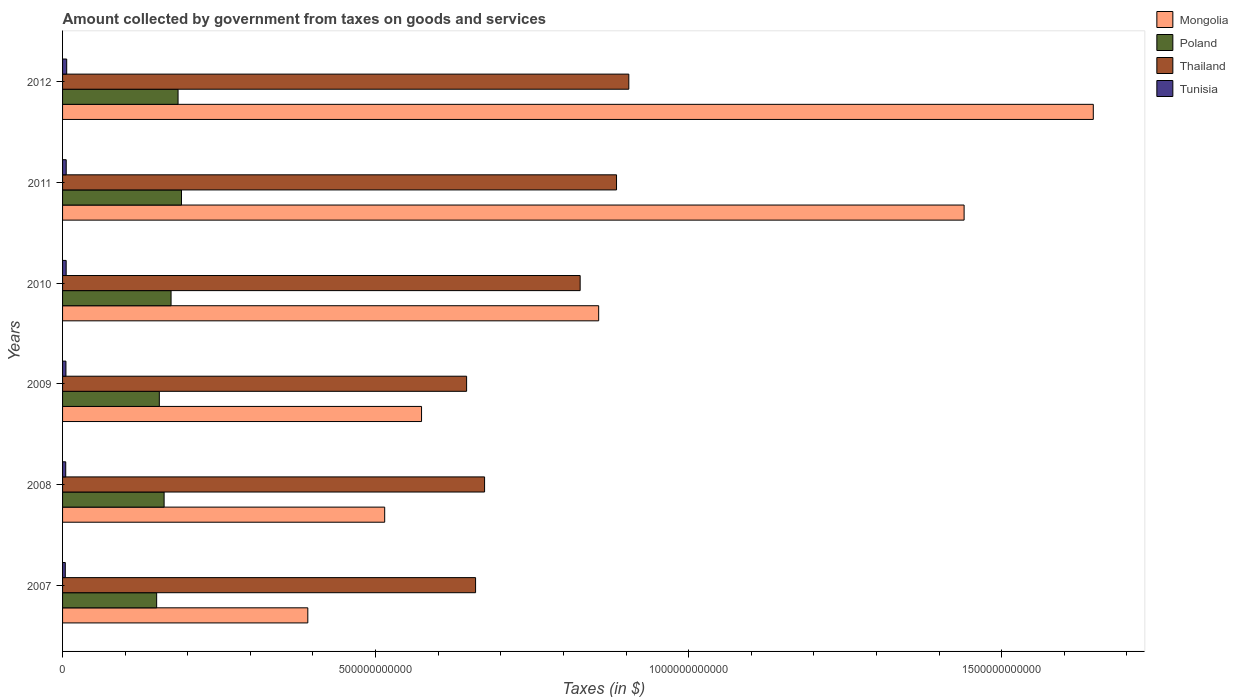How many different coloured bars are there?
Your response must be concise. 4. How many bars are there on the 6th tick from the top?
Your answer should be compact. 4. How many bars are there on the 4th tick from the bottom?
Your response must be concise. 4. What is the label of the 6th group of bars from the top?
Ensure brevity in your answer.  2007. In how many cases, is the number of bars for a given year not equal to the number of legend labels?
Keep it short and to the point. 0. What is the amount collected by government from taxes on goods and services in Poland in 2012?
Offer a very short reply. 1.84e+11. Across all years, what is the maximum amount collected by government from taxes on goods and services in Poland?
Your answer should be very brief. 1.90e+11. Across all years, what is the minimum amount collected by government from taxes on goods and services in Poland?
Your answer should be very brief. 1.50e+11. In which year was the amount collected by government from taxes on goods and services in Mongolia minimum?
Offer a terse response. 2007. What is the total amount collected by government from taxes on goods and services in Thailand in the graph?
Your answer should be compact. 4.60e+12. What is the difference between the amount collected by government from taxes on goods and services in Mongolia in 2010 and that in 2012?
Your answer should be very brief. -7.90e+11. What is the difference between the amount collected by government from taxes on goods and services in Poland in 2007 and the amount collected by government from taxes on goods and services in Tunisia in 2012?
Your response must be concise. 1.44e+11. What is the average amount collected by government from taxes on goods and services in Thailand per year?
Ensure brevity in your answer.  7.66e+11. In the year 2009, what is the difference between the amount collected by government from taxes on goods and services in Tunisia and amount collected by government from taxes on goods and services in Poland?
Provide a succinct answer. -1.49e+11. In how many years, is the amount collected by government from taxes on goods and services in Poland greater than 1300000000000 $?
Your answer should be very brief. 0. What is the ratio of the amount collected by government from taxes on goods and services in Tunisia in 2009 to that in 2010?
Your answer should be compact. 0.94. What is the difference between the highest and the second highest amount collected by government from taxes on goods and services in Tunisia?
Offer a very short reply. 7.81e+08. What is the difference between the highest and the lowest amount collected by government from taxes on goods and services in Thailand?
Keep it short and to the point. 2.59e+11. In how many years, is the amount collected by government from taxes on goods and services in Tunisia greater than the average amount collected by government from taxes on goods and services in Tunisia taken over all years?
Offer a terse response. 3. Is it the case that in every year, the sum of the amount collected by government from taxes on goods and services in Thailand and amount collected by government from taxes on goods and services in Mongolia is greater than the sum of amount collected by government from taxes on goods and services in Tunisia and amount collected by government from taxes on goods and services in Poland?
Your response must be concise. Yes. What does the 1st bar from the top in 2008 represents?
Your answer should be very brief. Tunisia. What does the 4th bar from the bottom in 2009 represents?
Your response must be concise. Tunisia. Is it the case that in every year, the sum of the amount collected by government from taxes on goods and services in Tunisia and amount collected by government from taxes on goods and services in Mongolia is greater than the amount collected by government from taxes on goods and services in Poland?
Keep it short and to the point. Yes. How many bars are there?
Give a very brief answer. 24. How many years are there in the graph?
Your answer should be compact. 6. What is the difference between two consecutive major ticks on the X-axis?
Make the answer very short. 5.00e+11. Does the graph contain any zero values?
Ensure brevity in your answer.  No. How are the legend labels stacked?
Ensure brevity in your answer.  Vertical. What is the title of the graph?
Make the answer very short. Amount collected by government from taxes on goods and services. Does "Turkey" appear as one of the legend labels in the graph?
Provide a short and direct response. No. What is the label or title of the X-axis?
Offer a very short reply. Taxes (in $). What is the label or title of the Y-axis?
Provide a short and direct response. Years. What is the Taxes (in $) of Mongolia in 2007?
Give a very brief answer. 3.92e+11. What is the Taxes (in $) in Poland in 2007?
Your answer should be very brief. 1.50e+11. What is the Taxes (in $) in Thailand in 2007?
Make the answer very short. 6.60e+11. What is the Taxes (in $) of Tunisia in 2007?
Your answer should be very brief. 4.37e+09. What is the Taxes (in $) of Mongolia in 2008?
Ensure brevity in your answer.  5.15e+11. What is the Taxes (in $) in Poland in 2008?
Offer a very short reply. 1.62e+11. What is the Taxes (in $) in Thailand in 2008?
Offer a very short reply. 6.74e+11. What is the Taxes (in $) of Tunisia in 2008?
Keep it short and to the point. 5.06e+09. What is the Taxes (in $) of Mongolia in 2009?
Your response must be concise. 5.73e+11. What is the Taxes (in $) of Poland in 2009?
Offer a very short reply. 1.55e+11. What is the Taxes (in $) in Thailand in 2009?
Give a very brief answer. 6.45e+11. What is the Taxes (in $) of Tunisia in 2009?
Give a very brief answer. 5.38e+09. What is the Taxes (in $) in Mongolia in 2010?
Ensure brevity in your answer.  8.56e+11. What is the Taxes (in $) of Poland in 2010?
Provide a short and direct response. 1.73e+11. What is the Taxes (in $) in Thailand in 2010?
Make the answer very short. 8.27e+11. What is the Taxes (in $) in Tunisia in 2010?
Your answer should be very brief. 5.75e+09. What is the Taxes (in $) in Mongolia in 2011?
Give a very brief answer. 1.44e+12. What is the Taxes (in $) of Poland in 2011?
Give a very brief answer. 1.90e+11. What is the Taxes (in $) of Thailand in 2011?
Provide a succinct answer. 8.85e+11. What is the Taxes (in $) in Tunisia in 2011?
Your answer should be very brief. 5.83e+09. What is the Taxes (in $) of Mongolia in 2012?
Keep it short and to the point. 1.65e+12. What is the Taxes (in $) in Poland in 2012?
Make the answer very short. 1.84e+11. What is the Taxes (in $) of Thailand in 2012?
Your response must be concise. 9.04e+11. What is the Taxes (in $) of Tunisia in 2012?
Make the answer very short. 6.61e+09. Across all years, what is the maximum Taxes (in $) of Mongolia?
Make the answer very short. 1.65e+12. Across all years, what is the maximum Taxes (in $) of Poland?
Keep it short and to the point. 1.90e+11. Across all years, what is the maximum Taxes (in $) in Thailand?
Give a very brief answer. 9.04e+11. Across all years, what is the maximum Taxes (in $) in Tunisia?
Offer a terse response. 6.61e+09. Across all years, what is the minimum Taxes (in $) of Mongolia?
Offer a very short reply. 3.92e+11. Across all years, what is the minimum Taxes (in $) of Poland?
Make the answer very short. 1.50e+11. Across all years, what is the minimum Taxes (in $) in Thailand?
Offer a terse response. 6.45e+11. Across all years, what is the minimum Taxes (in $) of Tunisia?
Provide a short and direct response. 4.37e+09. What is the total Taxes (in $) in Mongolia in the graph?
Keep it short and to the point. 5.42e+12. What is the total Taxes (in $) in Poland in the graph?
Your response must be concise. 1.01e+12. What is the total Taxes (in $) of Thailand in the graph?
Keep it short and to the point. 4.60e+12. What is the total Taxes (in $) in Tunisia in the graph?
Give a very brief answer. 3.30e+1. What is the difference between the Taxes (in $) in Mongolia in 2007 and that in 2008?
Offer a terse response. -1.23e+11. What is the difference between the Taxes (in $) of Poland in 2007 and that in 2008?
Your answer should be compact. -1.19e+1. What is the difference between the Taxes (in $) in Thailand in 2007 and that in 2008?
Ensure brevity in your answer.  -1.44e+1. What is the difference between the Taxes (in $) of Tunisia in 2007 and that in 2008?
Provide a succinct answer. -6.88e+08. What is the difference between the Taxes (in $) in Mongolia in 2007 and that in 2009?
Make the answer very short. -1.82e+11. What is the difference between the Taxes (in $) in Poland in 2007 and that in 2009?
Your answer should be compact. -4.26e+09. What is the difference between the Taxes (in $) in Thailand in 2007 and that in 2009?
Your response must be concise. 1.43e+1. What is the difference between the Taxes (in $) in Tunisia in 2007 and that in 2009?
Your answer should be compact. -1.00e+09. What is the difference between the Taxes (in $) of Mongolia in 2007 and that in 2010?
Make the answer very short. -4.65e+11. What is the difference between the Taxes (in $) of Poland in 2007 and that in 2010?
Your answer should be compact. -2.30e+1. What is the difference between the Taxes (in $) in Thailand in 2007 and that in 2010?
Provide a short and direct response. -1.67e+11. What is the difference between the Taxes (in $) of Tunisia in 2007 and that in 2010?
Your answer should be very brief. -1.37e+09. What is the difference between the Taxes (in $) of Mongolia in 2007 and that in 2011?
Your answer should be very brief. -1.05e+12. What is the difference between the Taxes (in $) of Poland in 2007 and that in 2011?
Give a very brief answer. -3.97e+1. What is the difference between the Taxes (in $) of Thailand in 2007 and that in 2011?
Make the answer very short. -2.25e+11. What is the difference between the Taxes (in $) of Tunisia in 2007 and that in 2011?
Give a very brief answer. -1.45e+09. What is the difference between the Taxes (in $) of Mongolia in 2007 and that in 2012?
Keep it short and to the point. -1.25e+12. What is the difference between the Taxes (in $) in Poland in 2007 and that in 2012?
Your answer should be compact. -3.42e+1. What is the difference between the Taxes (in $) in Thailand in 2007 and that in 2012?
Offer a terse response. -2.45e+11. What is the difference between the Taxes (in $) in Tunisia in 2007 and that in 2012?
Your answer should be compact. -2.24e+09. What is the difference between the Taxes (in $) in Mongolia in 2008 and that in 2009?
Give a very brief answer. -5.89e+1. What is the difference between the Taxes (in $) of Poland in 2008 and that in 2009?
Provide a short and direct response. 7.66e+09. What is the difference between the Taxes (in $) in Thailand in 2008 and that in 2009?
Provide a succinct answer. 2.87e+1. What is the difference between the Taxes (in $) of Tunisia in 2008 and that in 2009?
Offer a terse response. -3.16e+08. What is the difference between the Taxes (in $) in Mongolia in 2008 and that in 2010?
Your answer should be very brief. -3.42e+11. What is the difference between the Taxes (in $) in Poland in 2008 and that in 2010?
Offer a terse response. -1.11e+1. What is the difference between the Taxes (in $) in Thailand in 2008 and that in 2010?
Provide a short and direct response. -1.53e+11. What is the difference between the Taxes (in $) of Tunisia in 2008 and that in 2010?
Your answer should be very brief. -6.86e+08. What is the difference between the Taxes (in $) of Mongolia in 2008 and that in 2011?
Your response must be concise. -9.26e+11. What is the difference between the Taxes (in $) in Poland in 2008 and that in 2011?
Offer a very short reply. -2.77e+1. What is the difference between the Taxes (in $) of Thailand in 2008 and that in 2011?
Offer a very short reply. -2.11e+11. What is the difference between the Taxes (in $) of Tunisia in 2008 and that in 2011?
Provide a succinct answer. -7.66e+08. What is the difference between the Taxes (in $) of Mongolia in 2008 and that in 2012?
Offer a very short reply. -1.13e+12. What is the difference between the Taxes (in $) of Poland in 2008 and that in 2012?
Your answer should be very brief. -2.23e+1. What is the difference between the Taxes (in $) in Thailand in 2008 and that in 2012?
Offer a very short reply. -2.30e+11. What is the difference between the Taxes (in $) of Tunisia in 2008 and that in 2012?
Ensure brevity in your answer.  -1.55e+09. What is the difference between the Taxes (in $) of Mongolia in 2009 and that in 2010?
Make the answer very short. -2.83e+11. What is the difference between the Taxes (in $) in Poland in 2009 and that in 2010?
Provide a short and direct response. -1.88e+1. What is the difference between the Taxes (in $) in Thailand in 2009 and that in 2010?
Keep it short and to the point. -1.81e+11. What is the difference between the Taxes (in $) of Tunisia in 2009 and that in 2010?
Your response must be concise. -3.70e+08. What is the difference between the Taxes (in $) of Mongolia in 2009 and that in 2011?
Offer a terse response. -8.67e+11. What is the difference between the Taxes (in $) of Poland in 2009 and that in 2011?
Make the answer very short. -3.54e+1. What is the difference between the Taxes (in $) in Thailand in 2009 and that in 2011?
Your answer should be very brief. -2.39e+11. What is the difference between the Taxes (in $) of Tunisia in 2009 and that in 2011?
Provide a succinct answer. -4.50e+08. What is the difference between the Taxes (in $) in Mongolia in 2009 and that in 2012?
Ensure brevity in your answer.  -1.07e+12. What is the difference between the Taxes (in $) in Poland in 2009 and that in 2012?
Provide a short and direct response. -2.99e+1. What is the difference between the Taxes (in $) of Thailand in 2009 and that in 2012?
Provide a short and direct response. -2.59e+11. What is the difference between the Taxes (in $) of Tunisia in 2009 and that in 2012?
Your answer should be very brief. -1.23e+09. What is the difference between the Taxes (in $) of Mongolia in 2010 and that in 2011?
Your response must be concise. -5.84e+11. What is the difference between the Taxes (in $) of Poland in 2010 and that in 2011?
Provide a succinct answer. -1.66e+1. What is the difference between the Taxes (in $) of Thailand in 2010 and that in 2011?
Ensure brevity in your answer.  -5.81e+1. What is the difference between the Taxes (in $) in Tunisia in 2010 and that in 2011?
Ensure brevity in your answer.  -7.98e+07. What is the difference between the Taxes (in $) in Mongolia in 2010 and that in 2012?
Ensure brevity in your answer.  -7.90e+11. What is the difference between the Taxes (in $) of Poland in 2010 and that in 2012?
Ensure brevity in your answer.  -1.12e+1. What is the difference between the Taxes (in $) in Thailand in 2010 and that in 2012?
Your answer should be very brief. -7.77e+1. What is the difference between the Taxes (in $) of Tunisia in 2010 and that in 2012?
Give a very brief answer. -8.61e+08. What is the difference between the Taxes (in $) in Mongolia in 2011 and that in 2012?
Your answer should be compact. -2.06e+11. What is the difference between the Taxes (in $) in Poland in 2011 and that in 2012?
Offer a very short reply. 5.47e+09. What is the difference between the Taxes (in $) of Thailand in 2011 and that in 2012?
Ensure brevity in your answer.  -1.96e+1. What is the difference between the Taxes (in $) in Tunisia in 2011 and that in 2012?
Your response must be concise. -7.81e+08. What is the difference between the Taxes (in $) of Mongolia in 2007 and the Taxes (in $) of Poland in 2008?
Offer a terse response. 2.30e+11. What is the difference between the Taxes (in $) of Mongolia in 2007 and the Taxes (in $) of Thailand in 2008?
Provide a short and direct response. -2.82e+11. What is the difference between the Taxes (in $) in Mongolia in 2007 and the Taxes (in $) in Tunisia in 2008?
Provide a short and direct response. 3.87e+11. What is the difference between the Taxes (in $) of Poland in 2007 and the Taxes (in $) of Thailand in 2008?
Ensure brevity in your answer.  -5.24e+11. What is the difference between the Taxes (in $) in Poland in 2007 and the Taxes (in $) in Tunisia in 2008?
Offer a terse response. 1.45e+11. What is the difference between the Taxes (in $) of Thailand in 2007 and the Taxes (in $) of Tunisia in 2008?
Provide a succinct answer. 6.55e+11. What is the difference between the Taxes (in $) in Mongolia in 2007 and the Taxes (in $) in Poland in 2009?
Your response must be concise. 2.37e+11. What is the difference between the Taxes (in $) of Mongolia in 2007 and the Taxes (in $) of Thailand in 2009?
Your response must be concise. -2.54e+11. What is the difference between the Taxes (in $) of Mongolia in 2007 and the Taxes (in $) of Tunisia in 2009?
Ensure brevity in your answer.  3.86e+11. What is the difference between the Taxes (in $) of Poland in 2007 and the Taxes (in $) of Thailand in 2009?
Offer a very short reply. -4.95e+11. What is the difference between the Taxes (in $) in Poland in 2007 and the Taxes (in $) in Tunisia in 2009?
Provide a succinct answer. 1.45e+11. What is the difference between the Taxes (in $) of Thailand in 2007 and the Taxes (in $) of Tunisia in 2009?
Provide a succinct answer. 6.54e+11. What is the difference between the Taxes (in $) of Mongolia in 2007 and the Taxes (in $) of Poland in 2010?
Ensure brevity in your answer.  2.18e+11. What is the difference between the Taxes (in $) in Mongolia in 2007 and the Taxes (in $) in Thailand in 2010?
Ensure brevity in your answer.  -4.35e+11. What is the difference between the Taxes (in $) of Mongolia in 2007 and the Taxes (in $) of Tunisia in 2010?
Ensure brevity in your answer.  3.86e+11. What is the difference between the Taxes (in $) in Poland in 2007 and the Taxes (in $) in Thailand in 2010?
Ensure brevity in your answer.  -6.76e+11. What is the difference between the Taxes (in $) in Poland in 2007 and the Taxes (in $) in Tunisia in 2010?
Keep it short and to the point. 1.45e+11. What is the difference between the Taxes (in $) in Thailand in 2007 and the Taxes (in $) in Tunisia in 2010?
Offer a very short reply. 6.54e+11. What is the difference between the Taxes (in $) of Mongolia in 2007 and the Taxes (in $) of Poland in 2011?
Give a very brief answer. 2.02e+11. What is the difference between the Taxes (in $) in Mongolia in 2007 and the Taxes (in $) in Thailand in 2011?
Give a very brief answer. -4.93e+11. What is the difference between the Taxes (in $) in Mongolia in 2007 and the Taxes (in $) in Tunisia in 2011?
Make the answer very short. 3.86e+11. What is the difference between the Taxes (in $) in Poland in 2007 and the Taxes (in $) in Thailand in 2011?
Give a very brief answer. -7.35e+11. What is the difference between the Taxes (in $) of Poland in 2007 and the Taxes (in $) of Tunisia in 2011?
Your answer should be very brief. 1.44e+11. What is the difference between the Taxes (in $) of Thailand in 2007 and the Taxes (in $) of Tunisia in 2011?
Your answer should be compact. 6.54e+11. What is the difference between the Taxes (in $) of Mongolia in 2007 and the Taxes (in $) of Poland in 2012?
Your answer should be compact. 2.07e+11. What is the difference between the Taxes (in $) in Mongolia in 2007 and the Taxes (in $) in Thailand in 2012?
Offer a very short reply. -5.13e+11. What is the difference between the Taxes (in $) in Mongolia in 2007 and the Taxes (in $) in Tunisia in 2012?
Your answer should be very brief. 3.85e+11. What is the difference between the Taxes (in $) in Poland in 2007 and the Taxes (in $) in Thailand in 2012?
Your response must be concise. -7.54e+11. What is the difference between the Taxes (in $) in Poland in 2007 and the Taxes (in $) in Tunisia in 2012?
Offer a terse response. 1.44e+11. What is the difference between the Taxes (in $) of Thailand in 2007 and the Taxes (in $) of Tunisia in 2012?
Your answer should be very brief. 6.53e+11. What is the difference between the Taxes (in $) of Mongolia in 2008 and the Taxes (in $) of Poland in 2009?
Give a very brief answer. 3.60e+11. What is the difference between the Taxes (in $) of Mongolia in 2008 and the Taxes (in $) of Thailand in 2009?
Provide a short and direct response. -1.31e+11. What is the difference between the Taxes (in $) in Mongolia in 2008 and the Taxes (in $) in Tunisia in 2009?
Ensure brevity in your answer.  5.09e+11. What is the difference between the Taxes (in $) of Poland in 2008 and the Taxes (in $) of Thailand in 2009?
Make the answer very short. -4.83e+11. What is the difference between the Taxes (in $) in Poland in 2008 and the Taxes (in $) in Tunisia in 2009?
Offer a very short reply. 1.57e+11. What is the difference between the Taxes (in $) in Thailand in 2008 and the Taxes (in $) in Tunisia in 2009?
Provide a succinct answer. 6.69e+11. What is the difference between the Taxes (in $) of Mongolia in 2008 and the Taxes (in $) of Poland in 2010?
Keep it short and to the point. 3.41e+11. What is the difference between the Taxes (in $) in Mongolia in 2008 and the Taxes (in $) in Thailand in 2010?
Keep it short and to the point. -3.12e+11. What is the difference between the Taxes (in $) in Mongolia in 2008 and the Taxes (in $) in Tunisia in 2010?
Make the answer very short. 5.09e+11. What is the difference between the Taxes (in $) of Poland in 2008 and the Taxes (in $) of Thailand in 2010?
Offer a very short reply. -6.65e+11. What is the difference between the Taxes (in $) of Poland in 2008 and the Taxes (in $) of Tunisia in 2010?
Ensure brevity in your answer.  1.56e+11. What is the difference between the Taxes (in $) in Thailand in 2008 and the Taxes (in $) in Tunisia in 2010?
Give a very brief answer. 6.68e+11. What is the difference between the Taxes (in $) in Mongolia in 2008 and the Taxes (in $) in Poland in 2011?
Give a very brief answer. 3.25e+11. What is the difference between the Taxes (in $) of Mongolia in 2008 and the Taxes (in $) of Thailand in 2011?
Provide a short and direct response. -3.70e+11. What is the difference between the Taxes (in $) in Mongolia in 2008 and the Taxes (in $) in Tunisia in 2011?
Provide a short and direct response. 5.09e+11. What is the difference between the Taxes (in $) in Poland in 2008 and the Taxes (in $) in Thailand in 2011?
Provide a short and direct response. -7.23e+11. What is the difference between the Taxes (in $) of Poland in 2008 and the Taxes (in $) of Tunisia in 2011?
Ensure brevity in your answer.  1.56e+11. What is the difference between the Taxes (in $) of Thailand in 2008 and the Taxes (in $) of Tunisia in 2011?
Make the answer very short. 6.68e+11. What is the difference between the Taxes (in $) of Mongolia in 2008 and the Taxes (in $) of Poland in 2012?
Offer a very short reply. 3.30e+11. What is the difference between the Taxes (in $) in Mongolia in 2008 and the Taxes (in $) in Thailand in 2012?
Your answer should be compact. -3.90e+11. What is the difference between the Taxes (in $) of Mongolia in 2008 and the Taxes (in $) of Tunisia in 2012?
Your answer should be very brief. 5.08e+11. What is the difference between the Taxes (in $) in Poland in 2008 and the Taxes (in $) in Thailand in 2012?
Ensure brevity in your answer.  -7.42e+11. What is the difference between the Taxes (in $) in Poland in 2008 and the Taxes (in $) in Tunisia in 2012?
Offer a very short reply. 1.56e+11. What is the difference between the Taxes (in $) of Thailand in 2008 and the Taxes (in $) of Tunisia in 2012?
Ensure brevity in your answer.  6.67e+11. What is the difference between the Taxes (in $) in Mongolia in 2009 and the Taxes (in $) in Poland in 2010?
Your answer should be compact. 4.00e+11. What is the difference between the Taxes (in $) in Mongolia in 2009 and the Taxes (in $) in Thailand in 2010?
Give a very brief answer. -2.53e+11. What is the difference between the Taxes (in $) in Mongolia in 2009 and the Taxes (in $) in Tunisia in 2010?
Your answer should be compact. 5.68e+11. What is the difference between the Taxes (in $) of Poland in 2009 and the Taxes (in $) of Thailand in 2010?
Your answer should be very brief. -6.72e+11. What is the difference between the Taxes (in $) of Poland in 2009 and the Taxes (in $) of Tunisia in 2010?
Your answer should be very brief. 1.49e+11. What is the difference between the Taxes (in $) of Thailand in 2009 and the Taxes (in $) of Tunisia in 2010?
Keep it short and to the point. 6.40e+11. What is the difference between the Taxes (in $) in Mongolia in 2009 and the Taxes (in $) in Poland in 2011?
Keep it short and to the point. 3.83e+11. What is the difference between the Taxes (in $) of Mongolia in 2009 and the Taxes (in $) of Thailand in 2011?
Offer a terse response. -3.11e+11. What is the difference between the Taxes (in $) of Mongolia in 2009 and the Taxes (in $) of Tunisia in 2011?
Your answer should be very brief. 5.68e+11. What is the difference between the Taxes (in $) in Poland in 2009 and the Taxes (in $) in Thailand in 2011?
Provide a short and direct response. -7.30e+11. What is the difference between the Taxes (in $) of Poland in 2009 and the Taxes (in $) of Tunisia in 2011?
Provide a succinct answer. 1.49e+11. What is the difference between the Taxes (in $) in Thailand in 2009 and the Taxes (in $) in Tunisia in 2011?
Ensure brevity in your answer.  6.40e+11. What is the difference between the Taxes (in $) in Mongolia in 2009 and the Taxes (in $) in Poland in 2012?
Make the answer very short. 3.89e+11. What is the difference between the Taxes (in $) of Mongolia in 2009 and the Taxes (in $) of Thailand in 2012?
Your answer should be very brief. -3.31e+11. What is the difference between the Taxes (in $) of Mongolia in 2009 and the Taxes (in $) of Tunisia in 2012?
Make the answer very short. 5.67e+11. What is the difference between the Taxes (in $) in Poland in 2009 and the Taxes (in $) in Thailand in 2012?
Offer a very short reply. -7.50e+11. What is the difference between the Taxes (in $) in Poland in 2009 and the Taxes (in $) in Tunisia in 2012?
Your answer should be compact. 1.48e+11. What is the difference between the Taxes (in $) of Thailand in 2009 and the Taxes (in $) of Tunisia in 2012?
Make the answer very short. 6.39e+11. What is the difference between the Taxes (in $) of Mongolia in 2010 and the Taxes (in $) of Poland in 2011?
Provide a succinct answer. 6.66e+11. What is the difference between the Taxes (in $) of Mongolia in 2010 and the Taxes (in $) of Thailand in 2011?
Offer a very short reply. -2.85e+1. What is the difference between the Taxes (in $) of Mongolia in 2010 and the Taxes (in $) of Tunisia in 2011?
Provide a succinct answer. 8.51e+11. What is the difference between the Taxes (in $) in Poland in 2010 and the Taxes (in $) in Thailand in 2011?
Make the answer very short. -7.12e+11. What is the difference between the Taxes (in $) of Poland in 2010 and the Taxes (in $) of Tunisia in 2011?
Your answer should be compact. 1.67e+11. What is the difference between the Taxes (in $) of Thailand in 2010 and the Taxes (in $) of Tunisia in 2011?
Offer a very short reply. 8.21e+11. What is the difference between the Taxes (in $) in Mongolia in 2010 and the Taxes (in $) in Poland in 2012?
Provide a short and direct response. 6.72e+11. What is the difference between the Taxes (in $) in Mongolia in 2010 and the Taxes (in $) in Thailand in 2012?
Provide a succinct answer. -4.81e+1. What is the difference between the Taxes (in $) in Mongolia in 2010 and the Taxes (in $) in Tunisia in 2012?
Your answer should be very brief. 8.50e+11. What is the difference between the Taxes (in $) in Poland in 2010 and the Taxes (in $) in Thailand in 2012?
Offer a very short reply. -7.31e+11. What is the difference between the Taxes (in $) of Poland in 2010 and the Taxes (in $) of Tunisia in 2012?
Offer a very short reply. 1.67e+11. What is the difference between the Taxes (in $) of Thailand in 2010 and the Taxes (in $) of Tunisia in 2012?
Provide a succinct answer. 8.20e+11. What is the difference between the Taxes (in $) of Mongolia in 2011 and the Taxes (in $) of Poland in 2012?
Offer a terse response. 1.26e+12. What is the difference between the Taxes (in $) in Mongolia in 2011 and the Taxes (in $) in Thailand in 2012?
Your response must be concise. 5.36e+11. What is the difference between the Taxes (in $) in Mongolia in 2011 and the Taxes (in $) in Tunisia in 2012?
Provide a short and direct response. 1.43e+12. What is the difference between the Taxes (in $) of Poland in 2011 and the Taxes (in $) of Thailand in 2012?
Your answer should be very brief. -7.15e+11. What is the difference between the Taxes (in $) of Poland in 2011 and the Taxes (in $) of Tunisia in 2012?
Offer a terse response. 1.83e+11. What is the difference between the Taxes (in $) in Thailand in 2011 and the Taxes (in $) in Tunisia in 2012?
Ensure brevity in your answer.  8.78e+11. What is the average Taxes (in $) in Mongolia per year?
Offer a very short reply. 9.04e+11. What is the average Taxes (in $) of Poland per year?
Make the answer very short. 1.69e+11. What is the average Taxes (in $) in Thailand per year?
Your answer should be very brief. 7.66e+11. What is the average Taxes (in $) of Tunisia per year?
Your response must be concise. 5.50e+09. In the year 2007, what is the difference between the Taxes (in $) of Mongolia and Taxes (in $) of Poland?
Your answer should be compact. 2.41e+11. In the year 2007, what is the difference between the Taxes (in $) of Mongolia and Taxes (in $) of Thailand?
Offer a terse response. -2.68e+11. In the year 2007, what is the difference between the Taxes (in $) of Mongolia and Taxes (in $) of Tunisia?
Your response must be concise. 3.87e+11. In the year 2007, what is the difference between the Taxes (in $) in Poland and Taxes (in $) in Thailand?
Keep it short and to the point. -5.09e+11. In the year 2007, what is the difference between the Taxes (in $) in Poland and Taxes (in $) in Tunisia?
Your response must be concise. 1.46e+11. In the year 2007, what is the difference between the Taxes (in $) of Thailand and Taxes (in $) of Tunisia?
Give a very brief answer. 6.55e+11. In the year 2008, what is the difference between the Taxes (in $) of Mongolia and Taxes (in $) of Poland?
Your answer should be very brief. 3.52e+11. In the year 2008, what is the difference between the Taxes (in $) of Mongolia and Taxes (in $) of Thailand?
Give a very brief answer. -1.60e+11. In the year 2008, what is the difference between the Taxes (in $) in Mongolia and Taxes (in $) in Tunisia?
Ensure brevity in your answer.  5.09e+11. In the year 2008, what is the difference between the Taxes (in $) of Poland and Taxes (in $) of Thailand?
Your answer should be compact. -5.12e+11. In the year 2008, what is the difference between the Taxes (in $) of Poland and Taxes (in $) of Tunisia?
Your answer should be very brief. 1.57e+11. In the year 2008, what is the difference between the Taxes (in $) in Thailand and Taxes (in $) in Tunisia?
Provide a succinct answer. 6.69e+11. In the year 2009, what is the difference between the Taxes (in $) in Mongolia and Taxes (in $) in Poland?
Your answer should be very brief. 4.19e+11. In the year 2009, what is the difference between the Taxes (in $) in Mongolia and Taxes (in $) in Thailand?
Ensure brevity in your answer.  -7.20e+1. In the year 2009, what is the difference between the Taxes (in $) in Mongolia and Taxes (in $) in Tunisia?
Your response must be concise. 5.68e+11. In the year 2009, what is the difference between the Taxes (in $) of Poland and Taxes (in $) of Thailand?
Provide a short and direct response. -4.91e+11. In the year 2009, what is the difference between the Taxes (in $) of Poland and Taxes (in $) of Tunisia?
Offer a very short reply. 1.49e+11. In the year 2009, what is the difference between the Taxes (in $) of Thailand and Taxes (in $) of Tunisia?
Your response must be concise. 6.40e+11. In the year 2010, what is the difference between the Taxes (in $) in Mongolia and Taxes (in $) in Poland?
Your answer should be very brief. 6.83e+11. In the year 2010, what is the difference between the Taxes (in $) of Mongolia and Taxes (in $) of Thailand?
Keep it short and to the point. 2.96e+1. In the year 2010, what is the difference between the Taxes (in $) of Mongolia and Taxes (in $) of Tunisia?
Keep it short and to the point. 8.51e+11. In the year 2010, what is the difference between the Taxes (in $) in Poland and Taxes (in $) in Thailand?
Your answer should be very brief. -6.53e+11. In the year 2010, what is the difference between the Taxes (in $) in Poland and Taxes (in $) in Tunisia?
Offer a terse response. 1.68e+11. In the year 2010, what is the difference between the Taxes (in $) in Thailand and Taxes (in $) in Tunisia?
Provide a short and direct response. 8.21e+11. In the year 2011, what is the difference between the Taxes (in $) in Mongolia and Taxes (in $) in Poland?
Provide a short and direct response. 1.25e+12. In the year 2011, what is the difference between the Taxes (in $) of Mongolia and Taxes (in $) of Thailand?
Keep it short and to the point. 5.55e+11. In the year 2011, what is the difference between the Taxes (in $) of Mongolia and Taxes (in $) of Tunisia?
Provide a short and direct response. 1.43e+12. In the year 2011, what is the difference between the Taxes (in $) of Poland and Taxes (in $) of Thailand?
Your response must be concise. -6.95e+11. In the year 2011, what is the difference between the Taxes (in $) of Poland and Taxes (in $) of Tunisia?
Make the answer very short. 1.84e+11. In the year 2011, what is the difference between the Taxes (in $) in Thailand and Taxes (in $) in Tunisia?
Provide a short and direct response. 8.79e+11. In the year 2012, what is the difference between the Taxes (in $) of Mongolia and Taxes (in $) of Poland?
Offer a terse response. 1.46e+12. In the year 2012, what is the difference between the Taxes (in $) in Mongolia and Taxes (in $) in Thailand?
Your answer should be very brief. 7.42e+11. In the year 2012, what is the difference between the Taxes (in $) in Mongolia and Taxes (in $) in Tunisia?
Keep it short and to the point. 1.64e+12. In the year 2012, what is the difference between the Taxes (in $) of Poland and Taxes (in $) of Thailand?
Give a very brief answer. -7.20e+11. In the year 2012, what is the difference between the Taxes (in $) of Poland and Taxes (in $) of Tunisia?
Offer a terse response. 1.78e+11. In the year 2012, what is the difference between the Taxes (in $) of Thailand and Taxes (in $) of Tunisia?
Offer a very short reply. 8.98e+11. What is the ratio of the Taxes (in $) of Mongolia in 2007 to that in 2008?
Provide a succinct answer. 0.76. What is the ratio of the Taxes (in $) of Poland in 2007 to that in 2008?
Give a very brief answer. 0.93. What is the ratio of the Taxes (in $) of Thailand in 2007 to that in 2008?
Ensure brevity in your answer.  0.98. What is the ratio of the Taxes (in $) in Tunisia in 2007 to that in 2008?
Make the answer very short. 0.86. What is the ratio of the Taxes (in $) in Mongolia in 2007 to that in 2009?
Provide a short and direct response. 0.68. What is the ratio of the Taxes (in $) of Poland in 2007 to that in 2009?
Make the answer very short. 0.97. What is the ratio of the Taxes (in $) of Thailand in 2007 to that in 2009?
Your answer should be very brief. 1.02. What is the ratio of the Taxes (in $) in Tunisia in 2007 to that in 2009?
Keep it short and to the point. 0.81. What is the ratio of the Taxes (in $) in Mongolia in 2007 to that in 2010?
Your response must be concise. 0.46. What is the ratio of the Taxes (in $) of Poland in 2007 to that in 2010?
Provide a short and direct response. 0.87. What is the ratio of the Taxes (in $) of Thailand in 2007 to that in 2010?
Offer a terse response. 0.8. What is the ratio of the Taxes (in $) of Tunisia in 2007 to that in 2010?
Give a very brief answer. 0.76. What is the ratio of the Taxes (in $) of Mongolia in 2007 to that in 2011?
Your response must be concise. 0.27. What is the ratio of the Taxes (in $) of Poland in 2007 to that in 2011?
Provide a short and direct response. 0.79. What is the ratio of the Taxes (in $) of Thailand in 2007 to that in 2011?
Offer a very short reply. 0.75. What is the ratio of the Taxes (in $) of Tunisia in 2007 to that in 2011?
Offer a terse response. 0.75. What is the ratio of the Taxes (in $) of Mongolia in 2007 to that in 2012?
Make the answer very short. 0.24. What is the ratio of the Taxes (in $) in Poland in 2007 to that in 2012?
Your answer should be compact. 0.81. What is the ratio of the Taxes (in $) in Thailand in 2007 to that in 2012?
Your response must be concise. 0.73. What is the ratio of the Taxes (in $) in Tunisia in 2007 to that in 2012?
Ensure brevity in your answer.  0.66. What is the ratio of the Taxes (in $) in Mongolia in 2008 to that in 2009?
Offer a terse response. 0.9. What is the ratio of the Taxes (in $) in Poland in 2008 to that in 2009?
Make the answer very short. 1.05. What is the ratio of the Taxes (in $) in Thailand in 2008 to that in 2009?
Provide a short and direct response. 1.04. What is the ratio of the Taxes (in $) in Tunisia in 2008 to that in 2009?
Your response must be concise. 0.94. What is the ratio of the Taxes (in $) in Mongolia in 2008 to that in 2010?
Keep it short and to the point. 0.6. What is the ratio of the Taxes (in $) of Poland in 2008 to that in 2010?
Provide a succinct answer. 0.94. What is the ratio of the Taxes (in $) of Thailand in 2008 to that in 2010?
Offer a terse response. 0.82. What is the ratio of the Taxes (in $) of Tunisia in 2008 to that in 2010?
Offer a terse response. 0.88. What is the ratio of the Taxes (in $) of Mongolia in 2008 to that in 2011?
Your answer should be compact. 0.36. What is the ratio of the Taxes (in $) of Poland in 2008 to that in 2011?
Offer a terse response. 0.85. What is the ratio of the Taxes (in $) in Thailand in 2008 to that in 2011?
Provide a succinct answer. 0.76. What is the ratio of the Taxes (in $) in Tunisia in 2008 to that in 2011?
Provide a short and direct response. 0.87. What is the ratio of the Taxes (in $) of Mongolia in 2008 to that in 2012?
Your answer should be compact. 0.31. What is the ratio of the Taxes (in $) of Poland in 2008 to that in 2012?
Your response must be concise. 0.88. What is the ratio of the Taxes (in $) of Thailand in 2008 to that in 2012?
Provide a succinct answer. 0.75. What is the ratio of the Taxes (in $) of Tunisia in 2008 to that in 2012?
Ensure brevity in your answer.  0.77. What is the ratio of the Taxes (in $) in Mongolia in 2009 to that in 2010?
Offer a terse response. 0.67. What is the ratio of the Taxes (in $) in Poland in 2009 to that in 2010?
Provide a short and direct response. 0.89. What is the ratio of the Taxes (in $) of Thailand in 2009 to that in 2010?
Your answer should be very brief. 0.78. What is the ratio of the Taxes (in $) in Tunisia in 2009 to that in 2010?
Your answer should be compact. 0.94. What is the ratio of the Taxes (in $) of Mongolia in 2009 to that in 2011?
Provide a succinct answer. 0.4. What is the ratio of the Taxes (in $) in Poland in 2009 to that in 2011?
Provide a short and direct response. 0.81. What is the ratio of the Taxes (in $) of Thailand in 2009 to that in 2011?
Provide a succinct answer. 0.73. What is the ratio of the Taxes (in $) of Tunisia in 2009 to that in 2011?
Give a very brief answer. 0.92. What is the ratio of the Taxes (in $) in Mongolia in 2009 to that in 2012?
Your answer should be very brief. 0.35. What is the ratio of the Taxes (in $) in Poland in 2009 to that in 2012?
Offer a very short reply. 0.84. What is the ratio of the Taxes (in $) of Thailand in 2009 to that in 2012?
Provide a succinct answer. 0.71. What is the ratio of the Taxes (in $) of Tunisia in 2009 to that in 2012?
Your answer should be compact. 0.81. What is the ratio of the Taxes (in $) of Mongolia in 2010 to that in 2011?
Keep it short and to the point. 0.59. What is the ratio of the Taxes (in $) in Poland in 2010 to that in 2011?
Provide a short and direct response. 0.91. What is the ratio of the Taxes (in $) of Thailand in 2010 to that in 2011?
Make the answer very short. 0.93. What is the ratio of the Taxes (in $) of Tunisia in 2010 to that in 2011?
Provide a short and direct response. 0.99. What is the ratio of the Taxes (in $) in Mongolia in 2010 to that in 2012?
Provide a short and direct response. 0.52. What is the ratio of the Taxes (in $) in Poland in 2010 to that in 2012?
Your response must be concise. 0.94. What is the ratio of the Taxes (in $) in Thailand in 2010 to that in 2012?
Provide a succinct answer. 0.91. What is the ratio of the Taxes (in $) of Tunisia in 2010 to that in 2012?
Offer a terse response. 0.87. What is the ratio of the Taxes (in $) in Mongolia in 2011 to that in 2012?
Offer a terse response. 0.87. What is the ratio of the Taxes (in $) of Poland in 2011 to that in 2012?
Provide a short and direct response. 1.03. What is the ratio of the Taxes (in $) in Thailand in 2011 to that in 2012?
Offer a very short reply. 0.98. What is the ratio of the Taxes (in $) in Tunisia in 2011 to that in 2012?
Your answer should be compact. 0.88. What is the difference between the highest and the second highest Taxes (in $) of Mongolia?
Offer a very short reply. 2.06e+11. What is the difference between the highest and the second highest Taxes (in $) in Poland?
Your answer should be very brief. 5.47e+09. What is the difference between the highest and the second highest Taxes (in $) in Thailand?
Provide a short and direct response. 1.96e+1. What is the difference between the highest and the second highest Taxes (in $) in Tunisia?
Provide a short and direct response. 7.81e+08. What is the difference between the highest and the lowest Taxes (in $) in Mongolia?
Your answer should be compact. 1.25e+12. What is the difference between the highest and the lowest Taxes (in $) in Poland?
Make the answer very short. 3.97e+1. What is the difference between the highest and the lowest Taxes (in $) of Thailand?
Ensure brevity in your answer.  2.59e+11. What is the difference between the highest and the lowest Taxes (in $) of Tunisia?
Your answer should be compact. 2.24e+09. 